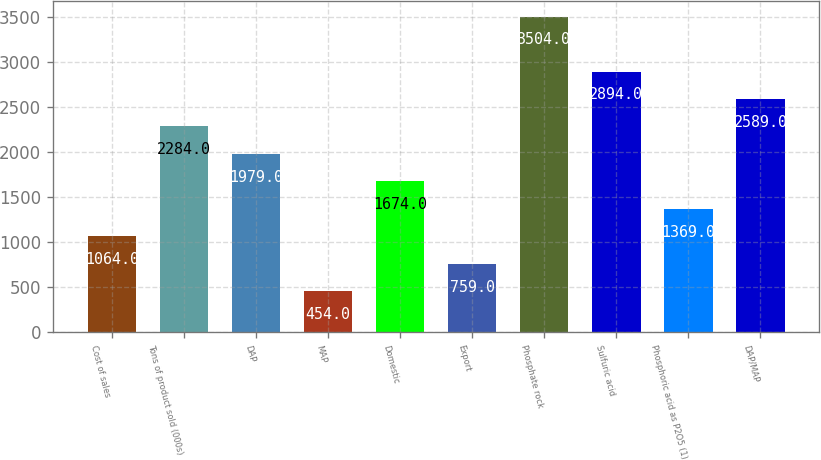Convert chart to OTSL. <chart><loc_0><loc_0><loc_500><loc_500><bar_chart><fcel>Cost of sales<fcel>Tons of product sold (000s)<fcel>DAP<fcel>MAP<fcel>Domestic<fcel>Export<fcel>Phosphate rock<fcel>Sulfuric acid<fcel>Phosphoric acid as P2O5 (1)<fcel>DAP/MAP<nl><fcel>1064<fcel>2284<fcel>1979<fcel>454<fcel>1674<fcel>759<fcel>3504<fcel>2894<fcel>1369<fcel>2589<nl></chart> 